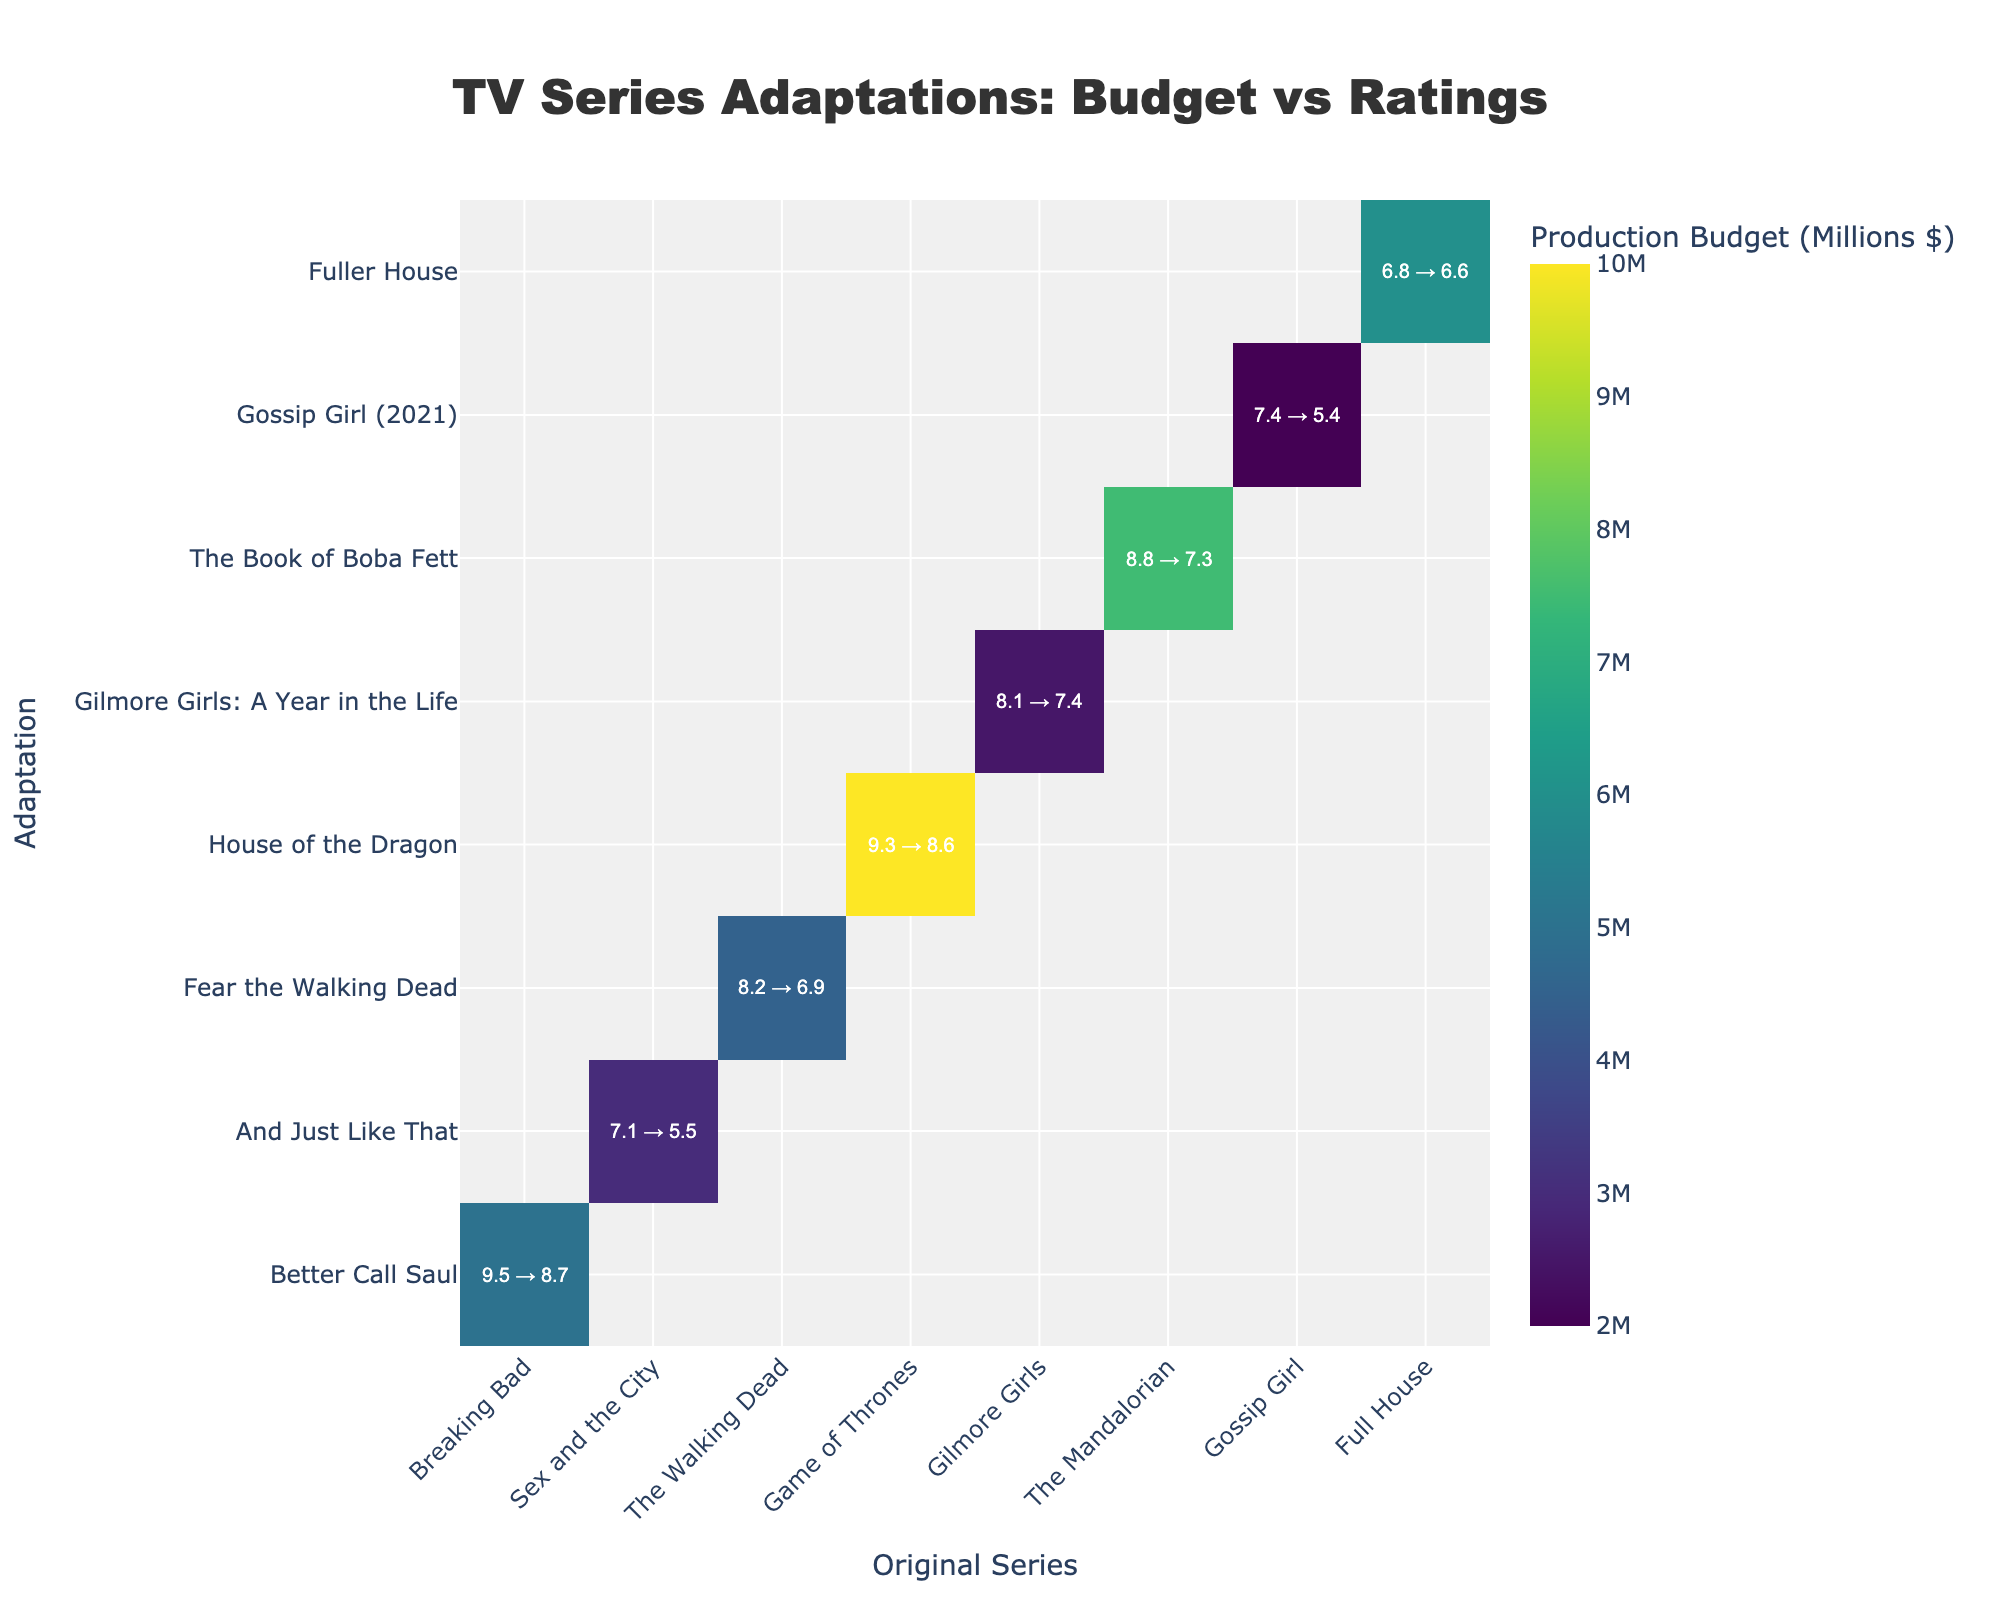How many original series and their adaptations are displayed in the heatmap? Count the number of unique original series on the x-axis and the number of unique adaptations on the y-axis. There are 8 unique original series and an equal number of unique adaptations.
Answer: 8 What is the title of the heatmap? The title is located at the top center of the heatmap in bold text. It reads, "TV Series Adaptations: Budget vs Ratings".
Answer: TV Series Adaptations: Budget vs Ratings Which adaptation has the highest production budget? Hover over each adaptation on the y-axis to view the pop-up information. "House of the Dragon" has the highest budget at $10 million.
Answer: House of the Dragon What is the production budget for "The Mandalorian"? Locate "The Mandalorian" on the x-axis, hover over it, and the pop-up information shows that its budget is $7.5 million.
Answer: $7.5 million What is the difference in ratings between the original "Breaking Bad" and its adaptation? Hover over the cells corresponding to "Breaking Bad" and "Better Call Saul", subtract the adaptation rating from the original rating: 9.5 - 8.7 = 0.8.
Answer: 0.8 Which original series has an adaptation with a better rating? Compare the ratings of original series and adaptations where the adaptation rating is higher. In this case, none of the adaptations have higher ratings than their originals.
Answer: None What is the average rating of all original series? Add all the ratings of the original series and divide by the number of original series. Ratings are: 9.5, 7.1, 8.2, 9.3, 8.1, 8.8, 7.4, 6.8. Sum = 65.2, average = 65.2 / 8 = 8.15.
Answer: 8.15 Compare the production budgets of "Gilmore Girls" and "Gossip Girl". Which one had a lower production budget? Hover over "Gilmore Girls" and "Gossip Girl" on the x-axis to check their budgets. "Gossip Girl" has a lower budget ($2 million) compared to "Gilmore Girls" ($2.5 million).
Answer: Gossip Girl Which cell in the heatmap corresponds to the smallest production budget? Identify the cell with the darkest color, then hover over it to view the details. This corresponds to "Gossip Girl" and "Gossip Girl (2021)" with a budget of $2 million.
Answer: Gossip Girl What are the ratings of "Sex and the City" and its adaptation? Hover over the cell corresponding to "Sex and the City" and "And Just Like That" to see the ratings: 7.1 (original) and 5.5 (adaptation).
Answer: 7.1 and 5.5 